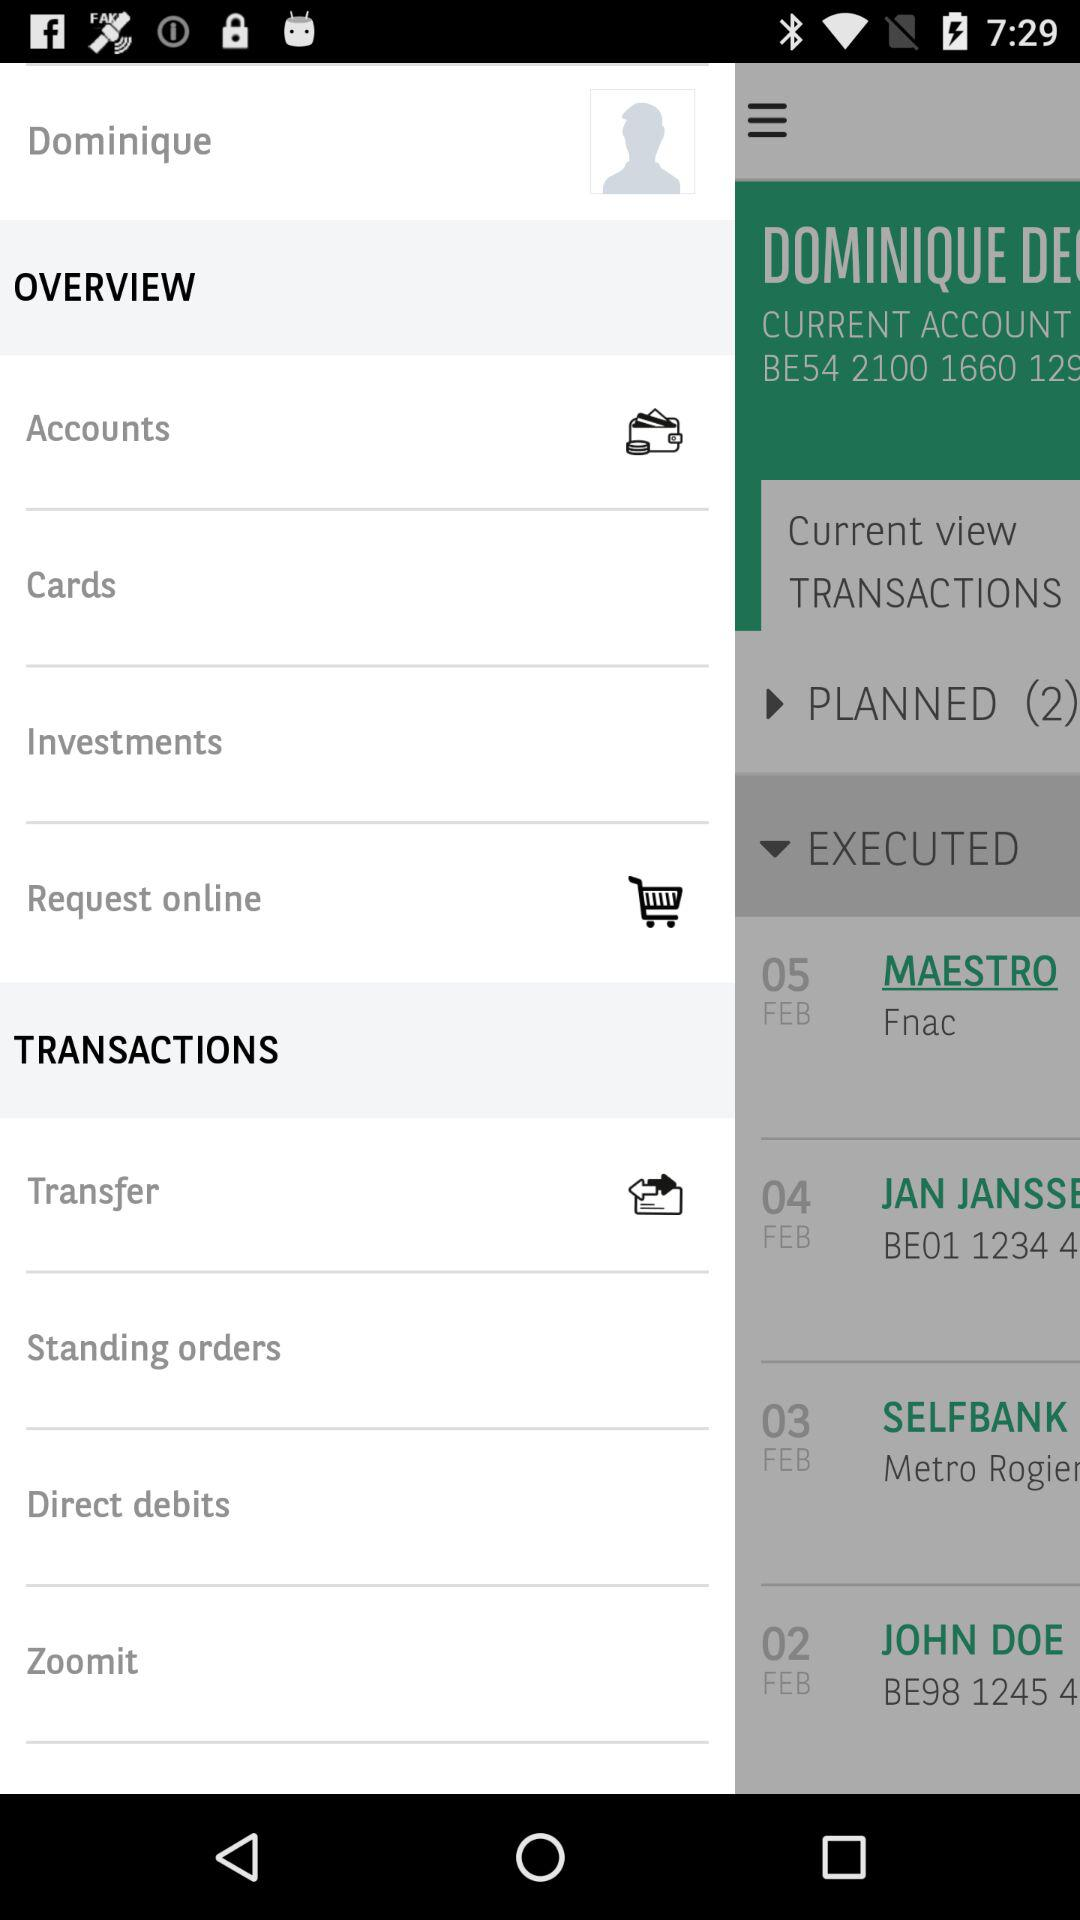What is the user name? The user name is Dominique. 